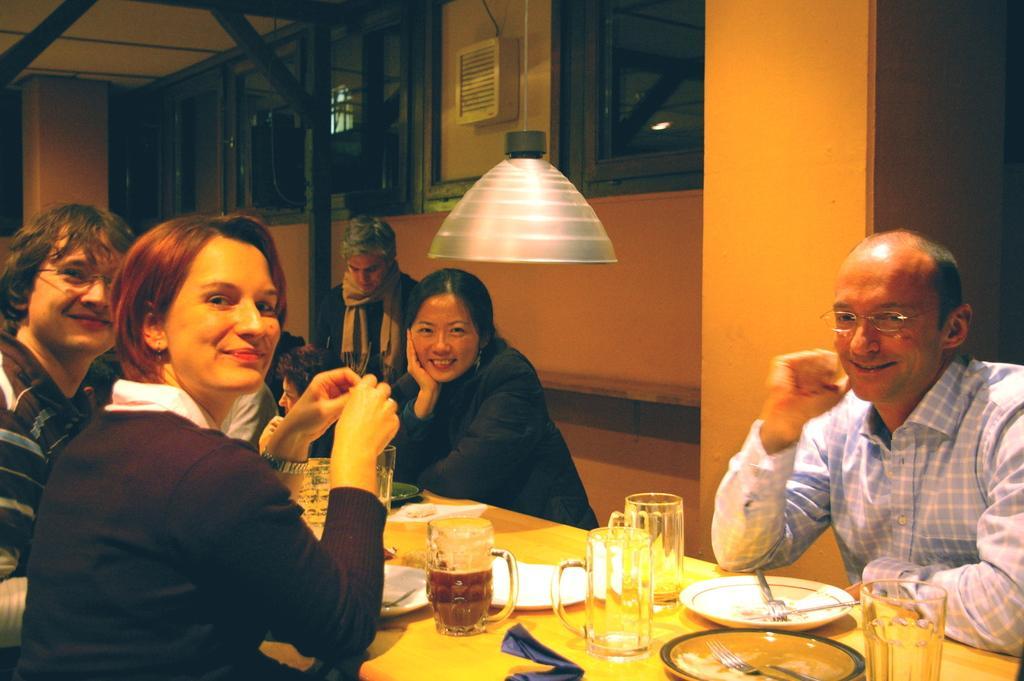Please provide a concise description of this image. In this image i can see a group of people who are sitting on a chair in front of a table. On the table we have a few plates , few glasses and other objects on it. 